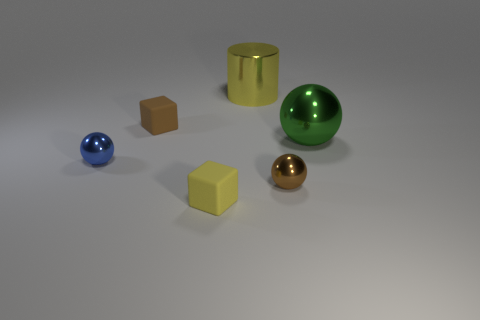There is a rubber thing in front of the small blue sphere; does it have the same size as the brown object right of the big yellow metal object?
Give a very brief answer. Yes. Is there anything else that has the same material as the big green ball?
Your response must be concise. Yes. There is a small thing to the right of the big shiny cylinder on the left side of the tiny sphere that is right of the big yellow object; what is its material?
Provide a short and direct response. Metal. Is the tiny brown metal thing the same shape as the tiny blue object?
Offer a very short reply. Yes. What is the material of the other thing that is the same shape as the yellow rubber thing?
Your response must be concise. Rubber. How many small objects are the same color as the cylinder?
Your answer should be compact. 1. There is a yellow cylinder that is the same material as the blue thing; what size is it?
Keep it short and to the point. Large. How many blue objects are either cylinders or small things?
Offer a very short reply. 1. How many large yellow things are to the left of the large object behind the large green metallic sphere?
Provide a short and direct response. 0. Is the number of metal things that are in front of the big green shiny sphere greater than the number of cylinders behind the tiny blue metallic thing?
Give a very brief answer. Yes. 